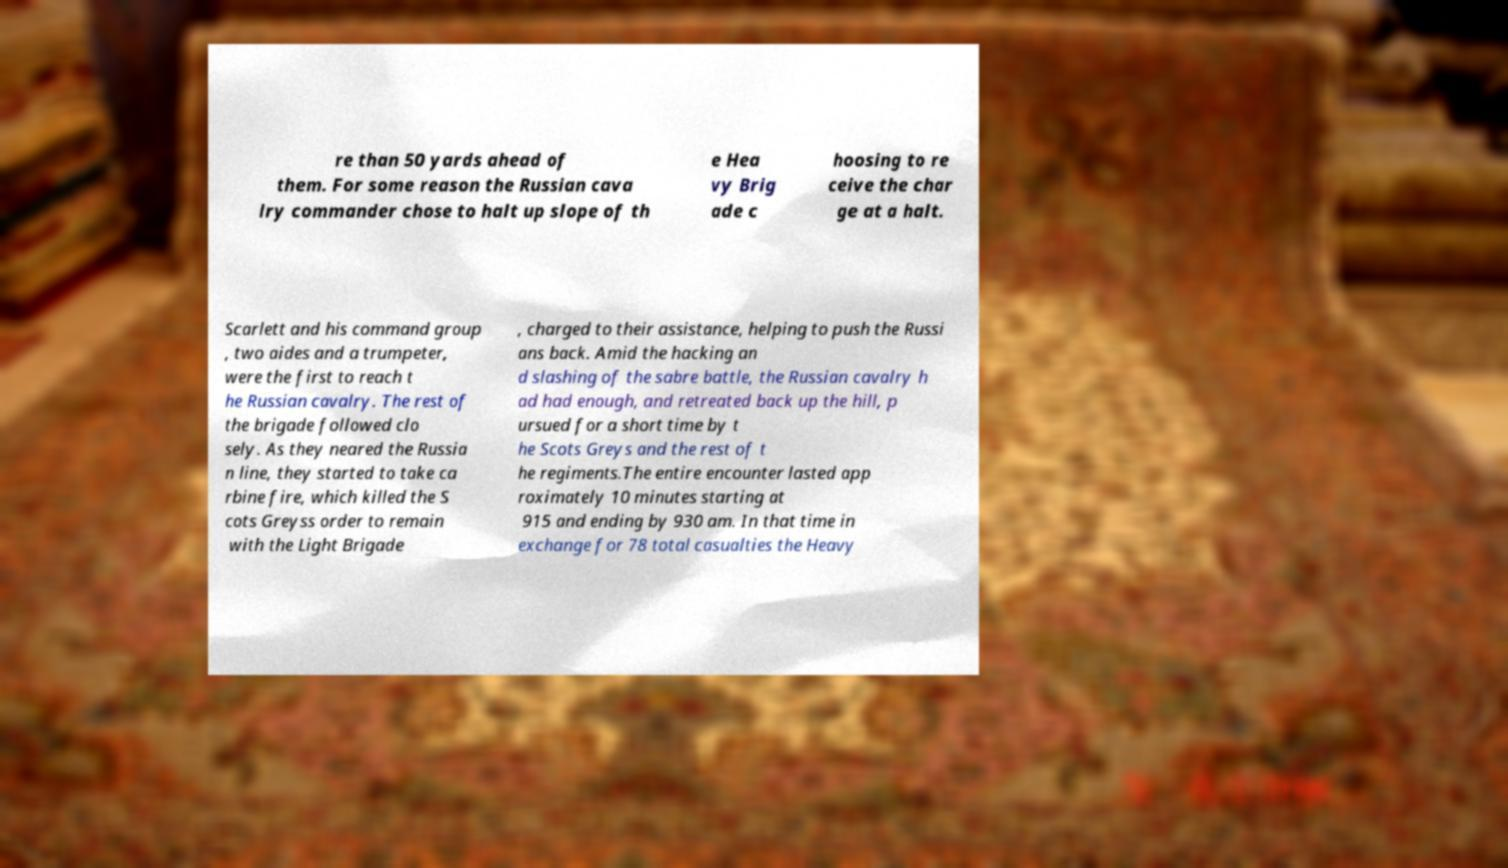I need the written content from this picture converted into text. Can you do that? re than 50 yards ahead of them. For some reason the Russian cava lry commander chose to halt up slope of th e Hea vy Brig ade c hoosing to re ceive the char ge at a halt. Scarlett and his command group , two aides and a trumpeter, were the first to reach t he Russian cavalry. The rest of the brigade followed clo sely. As they neared the Russia n line, they started to take ca rbine fire, which killed the S cots Greyss order to remain with the Light Brigade , charged to their assistance, helping to push the Russi ans back. Amid the hacking an d slashing of the sabre battle, the Russian cavalry h ad had enough, and retreated back up the hill, p ursued for a short time by t he Scots Greys and the rest of t he regiments.The entire encounter lasted app roximately 10 minutes starting at 915 and ending by 930 am. In that time in exchange for 78 total casualties the Heavy 